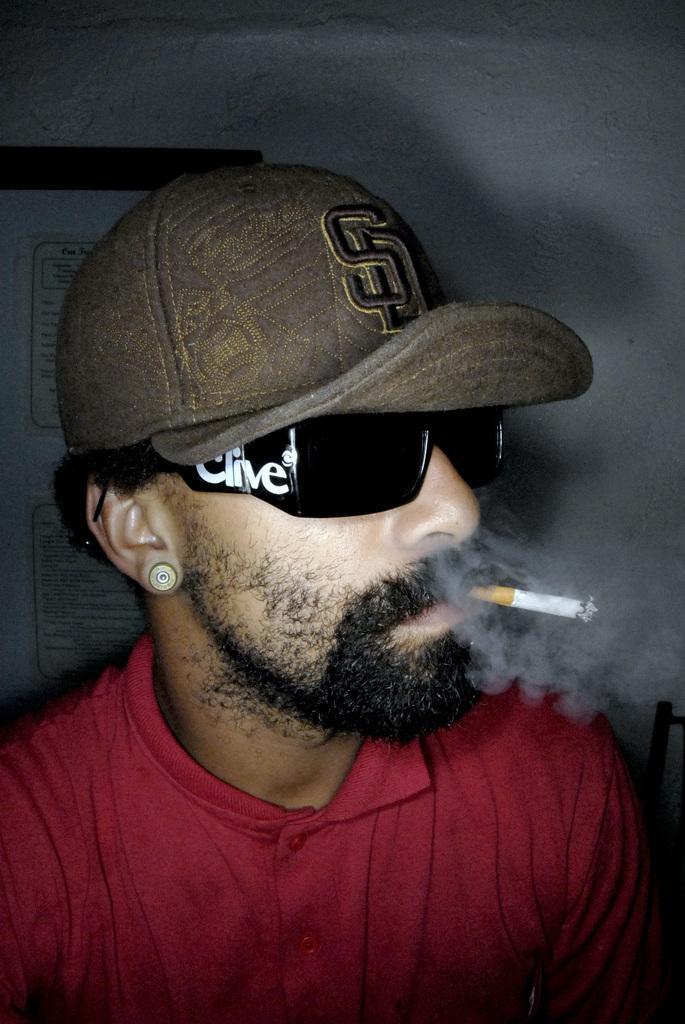How would you summarize this image in a sentence or two? This image consists of a man wearing a red T-shirt and a cap. He is smoking a cigarette. And he is wearing black shades. In the background, we can see a wall on which there is a frame. 